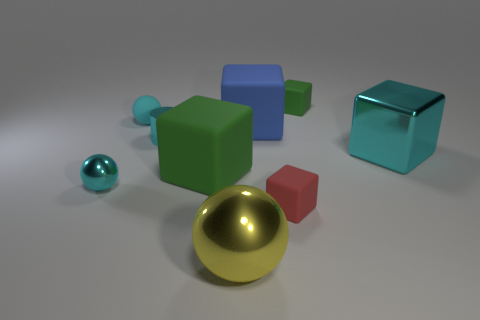Subtract all cyan shiny cubes. How many cubes are left? 4 Subtract all green cubes. How many were subtracted if there are1green cubes left? 1 Subtract 3 blocks. How many blocks are left? 2 Subtract all blue balls. Subtract all yellow cylinders. How many balls are left? 3 Subtract all brown balls. How many red cubes are left? 1 Subtract all large metal spheres. Subtract all large red metal spheres. How many objects are left? 8 Add 4 small cyan shiny spheres. How many small cyan shiny spheres are left? 5 Add 2 brown shiny balls. How many brown shiny balls exist? 2 Subtract all green blocks. How many blocks are left? 3 Subtract 0 purple blocks. How many objects are left? 9 